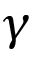<formula> <loc_0><loc_0><loc_500><loc_500>\gamma</formula> 